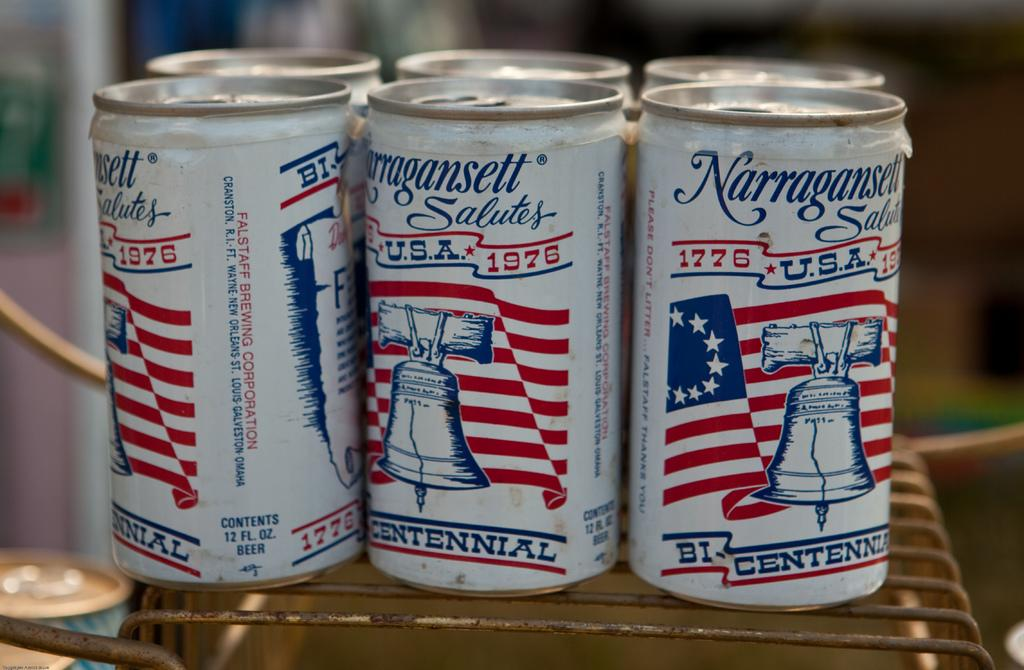<image>
Share a concise interpretation of the image provided. A six pack of Narragansett beer with the liberty bell on the cans. 